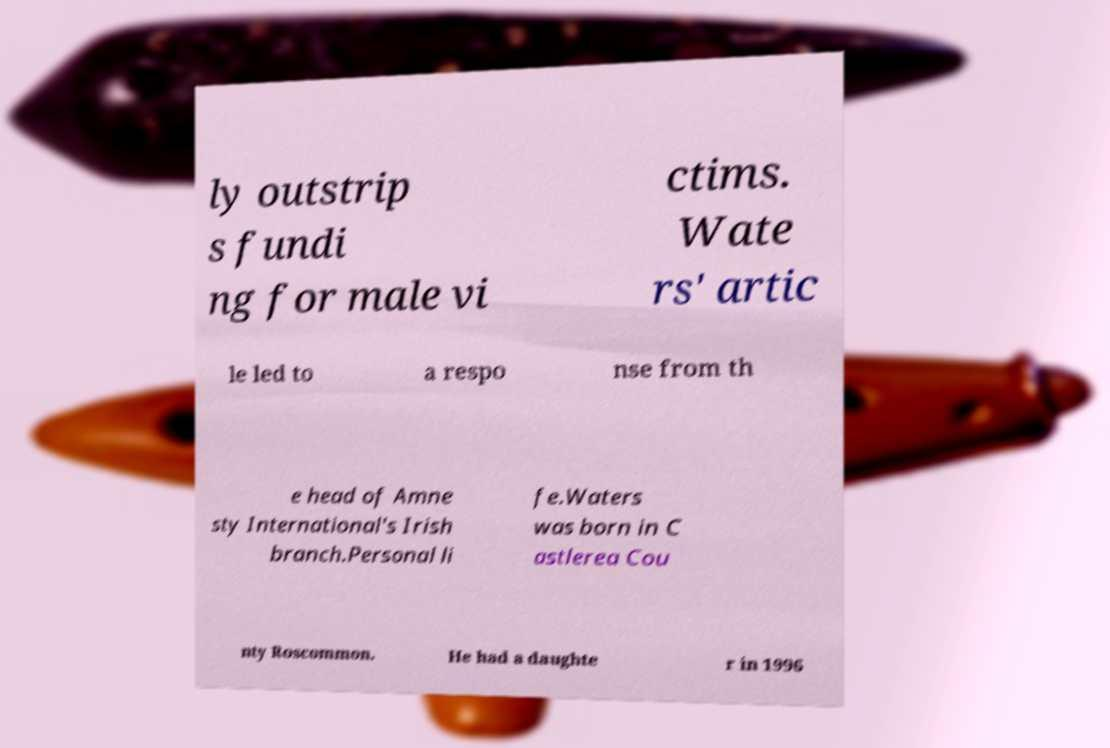There's text embedded in this image that I need extracted. Can you transcribe it verbatim? ly outstrip s fundi ng for male vi ctims. Wate rs' artic le led to a respo nse from th e head of Amne sty International's Irish branch.Personal li fe.Waters was born in C astlerea Cou nty Roscommon. He had a daughte r in 1996 